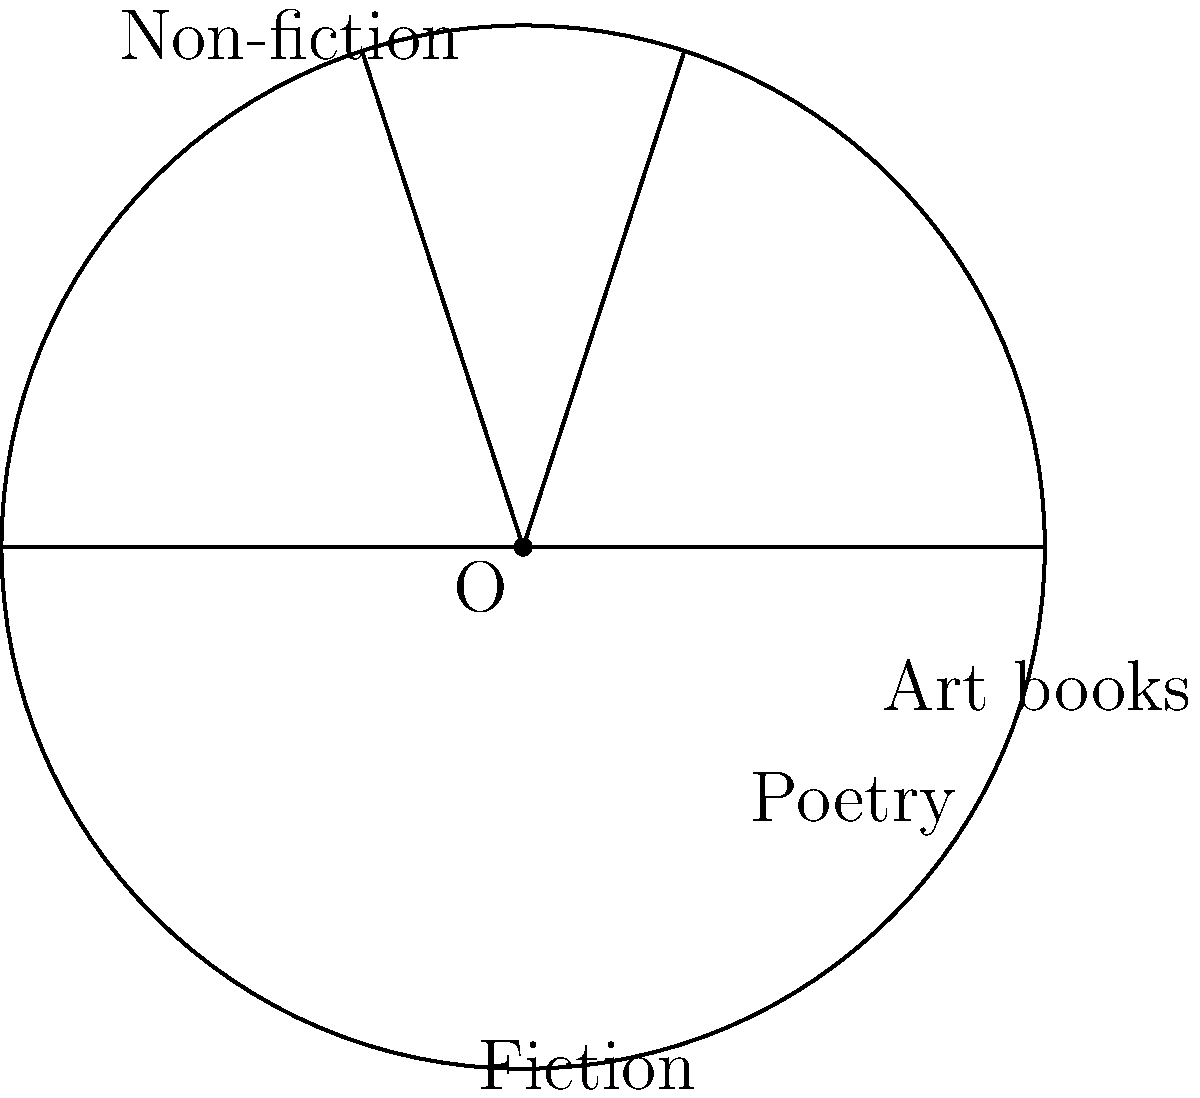A literary agent is analyzing the market share of different book genres. The circle represents the total market, and each sector represents a genre's share. If the radius of the circle is 10 cm and the central angle of the "Poetry" sector is $72^\circ$, what is the area of the "Poetry" sector in square centimeters? (Use $\pi = 3.14$) To find the area of the "Poetry" sector, we need to follow these steps:

1) The formula for the area of a sector is:
   $$A = \frac{\theta}{360^\circ} \times \pi r^2$$
   where $A$ is the area, $\theta$ is the central angle in degrees, and $r$ is the radius.

2) We are given:
   - Radius $r = 10$ cm
   - Central angle for "Poetry" $\theta = 72^\circ$
   - $\pi = 3.14$

3) Let's substitute these values into the formula:
   $$A = \frac{72^\circ}{360^\circ} \times 3.14 \times 10^2$$

4) Simplify:
   $$A = 0.2 \times 3.14 \times 100$$
   $$A = 62.8$$

5) Therefore, the area of the "Poetry" sector is 62.8 square centimeters.
Answer: 62.8 cm² 